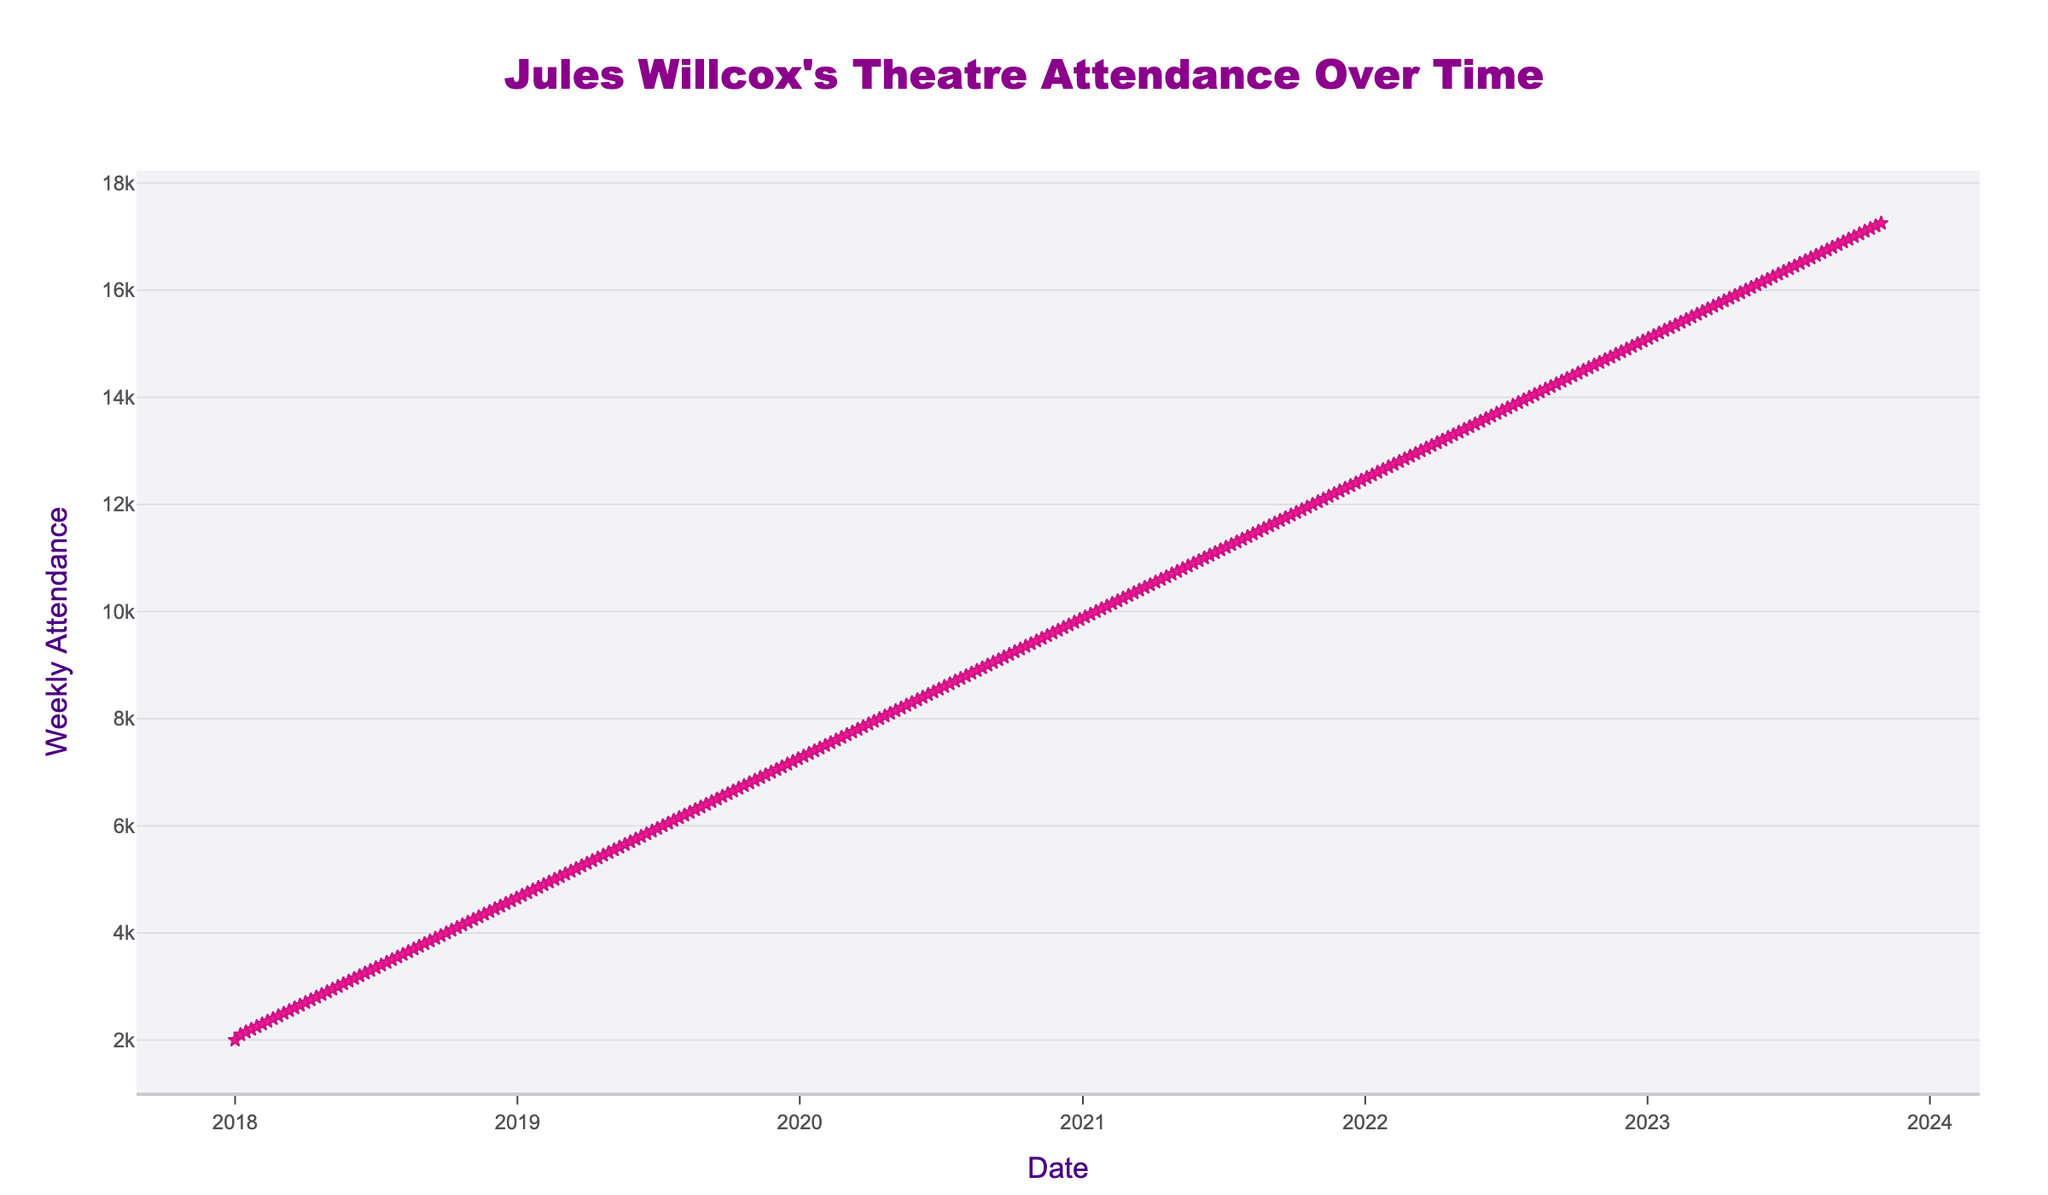What's the title of the plot? The title of the plot is usually located at the top center of the figure. By looking at the top center, we can see the title "Jules Willcox's Theatre Attendance Over Time" in bold and colorful text.
Answer: Jules Willcox's Theatre Attendance Over Time What does the y-axis represent? The y-axis on the left side of the plot is labeled with the term "Weekly Attendance". This indicates that the y-axis represents the weekly attendance at the theaters.
Answer: Weekly Attendance Between which years does the data span? Observing the x-axis at the bottom of the plot, we can see it starts at the beginning of the year 2018 and ends in the year 2023. Therefore, the plot spans data from 2018 to 2023.
Answer: 2018 to 2023 What was the weekly attendance at the end of 2019? To find the attendance at the end of 2019, we note the last point in the year 2019 from the bottom x-axis which corresponds to December 30, 2019. The y-value of that point is 7250.
Answer: 7250 How does the weekly attendance change over time? We can see from the plot that the weekly attendance of theaters featuring films with Jules Willcox generally increases over time. The line graph consistently moves upward from the beginning of 2018 to the end of 2023, indicating a continuous increase.
Answer: Increases over time What was the highest weekly attendance recorded, and when did it occur? The highest point on the y-axis, where the line graph hits its peak, should represent the highest weekly attendance. From the plot, this peak corresponds to the date Oct 30, 2023, and the attendance value is 17250.
Answer: 17250 on Oct 30, 2023 Compare the weekly attendance at the start and end of 2020. What can you observe? The weekly attendance at the beginning of 2020 (Jan 06, 2020) is 7300, and at the end of 2020 (Dec 28, 2020) is 9850. By subtracting 7300 from 9850, there was an increase of 2550 in weekly attendance over the year 2020.
Answer: Increased by 2550 What is the average weekly attendance for the year 2021? To calculate the average for 2021, we need the sum of all weekly attendances in 2021 divided by the number of weeks. There are 52 weeks in a year. Summing the weekly attendances for 2021 and dividing by 52, we get (9900 + 9950 + ... + 12450)/52 ≈ 11175 (given that trends show consistent value increments of 50 per week).
Answer: ≈ 11175 During which month in 2018 did the weekly attendance first reach 4000? Checking the line graph for when it first crosses the value 4000 on the y-axis and referencing the x-axis, it appears that the attendance first reaches 4000 in October 2018.
Answer: October 2018 What was the trend in weekly attendance from May 2021 to December 2021? By observing the line graph between May 2021 and December 2021, the weekly attendance appears to follow a steady upward trend. The values gradually increase each week during this period.
Answer: Steady upward trend 